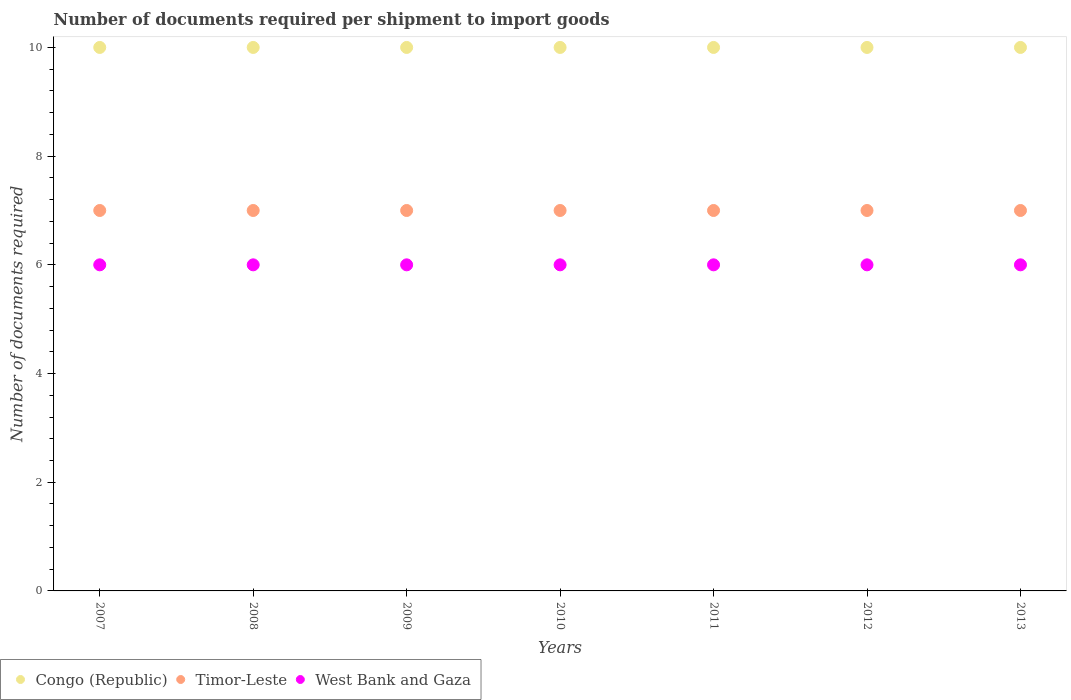How many different coloured dotlines are there?
Ensure brevity in your answer.  3. Is the number of dotlines equal to the number of legend labels?
Make the answer very short. Yes. What is the number of documents required per shipment to import goods in West Bank and Gaza in 2009?
Offer a terse response. 6. Across all years, what is the maximum number of documents required per shipment to import goods in Timor-Leste?
Your answer should be very brief. 7. In which year was the number of documents required per shipment to import goods in Timor-Leste maximum?
Your answer should be compact. 2007. In which year was the number of documents required per shipment to import goods in Congo (Republic) minimum?
Make the answer very short. 2007. What is the total number of documents required per shipment to import goods in West Bank and Gaza in the graph?
Offer a very short reply. 42. What is the difference between the number of documents required per shipment to import goods in West Bank and Gaza in 2011 and that in 2012?
Your answer should be compact. 0. What is the difference between the number of documents required per shipment to import goods in Congo (Republic) in 2011 and the number of documents required per shipment to import goods in Timor-Leste in 2009?
Make the answer very short. 3. What is the average number of documents required per shipment to import goods in Timor-Leste per year?
Make the answer very short. 7. In the year 2007, what is the difference between the number of documents required per shipment to import goods in Timor-Leste and number of documents required per shipment to import goods in West Bank and Gaza?
Offer a terse response. 1. In how many years, is the number of documents required per shipment to import goods in Timor-Leste greater than 6.4?
Your answer should be very brief. 7. What is the difference between the highest and the second highest number of documents required per shipment to import goods in Timor-Leste?
Offer a very short reply. 0. What is the difference between the highest and the lowest number of documents required per shipment to import goods in Timor-Leste?
Provide a succinct answer. 0. In how many years, is the number of documents required per shipment to import goods in West Bank and Gaza greater than the average number of documents required per shipment to import goods in West Bank and Gaza taken over all years?
Offer a very short reply. 0. Does the number of documents required per shipment to import goods in Congo (Republic) monotonically increase over the years?
Provide a short and direct response. No. Is the number of documents required per shipment to import goods in Congo (Republic) strictly greater than the number of documents required per shipment to import goods in Timor-Leste over the years?
Give a very brief answer. Yes. How many dotlines are there?
Provide a short and direct response. 3. Does the graph contain grids?
Give a very brief answer. No. Where does the legend appear in the graph?
Ensure brevity in your answer.  Bottom left. How are the legend labels stacked?
Keep it short and to the point. Horizontal. What is the title of the graph?
Offer a terse response. Number of documents required per shipment to import goods. What is the label or title of the X-axis?
Ensure brevity in your answer.  Years. What is the label or title of the Y-axis?
Your answer should be very brief. Number of documents required. What is the Number of documents required of Timor-Leste in 2007?
Your answer should be compact. 7. What is the Number of documents required of West Bank and Gaza in 2007?
Provide a short and direct response. 6. What is the Number of documents required in Congo (Republic) in 2008?
Offer a terse response. 10. What is the Number of documents required of Timor-Leste in 2008?
Your answer should be compact. 7. What is the Number of documents required in West Bank and Gaza in 2008?
Provide a short and direct response. 6. What is the Number of documents required in Congo (Republic) in 2009?
Your response must be concise. 10. What is the Number of documents required in Timor-Leste in 2010?
Make the answer very short. 7. What is the Number of documents required of West Bank and Gaza in 2010?
Ensure brevity in your answer.  6. What is the Number of documents required of Congo (Republic) in 2011?
Give a very brief answer. 10. What is the Number of documents required of Timor-Leste in 2012?
Offer a very short reply. 7. What is the Number of documents required of Timor-Leste in 2013?
Provide a short and direct response. 7. Across all years, what is the maximum Number of documents required of Timor-Leste?
Keep it short and to the point. 7. Across all years, what is the maximum Number of documents required in West Bank and Gaza?
Your answer should be compact. 6. Across all years, what is the minimum Number of documents required of Congo (Republic)?
Offer a very short reply. 10. Across all years, what is the minimum Number of documents required in West Bank and Gaza?
Give a very brief answer. 6. What is the total Number of documents required in Congo (Republic) in the graph?
Your answer should be very brief. 70. What is the total Number of documents required in Timor-Leste in the graph?
Give a very brief answer. 49. What is the difference between the Number of documents required of Congo (Republic) in 2007 and that in 2008?
Keep it short and to the point. 0. What is the difference between the Number of documents required in Timor-Leste in 2007 and that in 2008?
Offer a terse response. 0. What is the difference between the Number of documents required in Congo (Republic) in 2007 and that in 2009?
Make the answer very short. 0. What is the difference between the Number of documents required in Timor-Leste in 2007 and that in 2009?
Keep it short and to the point. 0. What is the difference between the Number of documents required in Congo (Republic) in 2007 and that in 2011?
Ensure brevity in your answer.  0. What is the difference between the Number of documents required in West Bank and Gaza in 2007 and that in 2011?
Keep it short and to the point. 0. What is the difference between the Number of documents required of Timor-Leste in 2007 and that in 2012?
Offer a very short reply. 0. What is the difference between the Number of documents required of Congo (Republic) in 2007 and that in 2013?
Give a very brief answer. 0. What is the difference between the Number of documents required of Timor-Leste in 2007 and that in 2013?
Your answer should be compact. 0. What is the difference between the Number of documents required in West Bank and Gaza in 2007 and that in 2013?
Give a very brief answer. 0. What is the difference between the Number of documents required of Congo (Republic) in 2008 and that in 2009?
Offer a terse response. 0. What is the difference between the Number of documents required in West Bank and Gaza in 2008 and that in 2011?
Your answer should be very brief. 0. What is the difference between the Number of documents required of West Bank and Gaza in 2008 and that in 2012?
Offer a terse response. 0. What is the difference between the Number of documents required in Congo (Republic) in 2008 and that in 2013?
Your response must be concise. 0. What is the difference between the Number of documents required in Congo (Republic) in 2009 and that in 2010?
Offer a terse response. 0. What is the difference between the Number of documents required in Timor-Leste in 2009 and that in 2010?
Offer a terse response. 0. What is the difference between the Number of documents required of West Bank and Gaza in 2009 and that in 2010?
Make the answer very short. 0. What is the difference between the Number of documents required in West Bank and Gaza in 2009 and that in 2012?
Provide a succinct answer. 0. What is the difference between the Number of documents required in Congo (Republic) in 2009 and that in 2013?
Your answer should be very brief. 0. What is the difference between the Number of documents required in Timor-Leste in 2009 and that in 2013?
Provide a short and direct response. 0. What is the difference between the Number of documents required in Timor-Leste in 2010 and that in 2011?
Make the answer very short. 0. What is the difference between the Number of documents required in Timor-Leste in 2010 and that in 2012?
Provide a short and direct response. 0. What is the difference between the Number of documents required in West Bank and Gaza in 2010 and that in 2012?
Your answer should be compact. 0. What is the difference between the Number of documents required in Congo (Republic) in 2010 and that in 2013?
Your response must be concise. 0. What is the difference between the Number of documents required of Timor-Leste in 2010 and that in 2013?
Your answer should be compact. 0. What is the difference between the Number of documents required of Congo (Republic) in 2011 and that in 2012?
Your answer should be compact. 0. What is the difference between the Number of documents required of Congo (Republic) in 2011 and that in 2013?
Ensure brevity in your answer.  0. What is the difference between the Number of documents required of Congo (Republic) in 2012 and that in 2013?
Keep it short and to the point. 0. What is the difference between the Number of documents required in West Bank and Gaza in 2012 and that in 2013?
Your answer should be very brief. 0. What is the difference between the Number of documents required of Congo (Republic) in 2007 and the Number of documents required of Timor-Leste in 2008?
Offer a very short reply. 3. What is the difference between the Number of documents required in Timor-Leste in 2007 and the Number of documents required in West Bank and Gaza in 2008?
Provide a short and direct response. 1. What is the difference between the Number of documents required of Congo (Republic) in 2007 and the Number of documents required of West Bank and Gaza in 2009?
Keep it short and to the point. 4. What is the difference between the Number of documents required in Congo (Republic) in 2007 and the Number of documents required in Timor-Leste in 2010?
Your answer should be compact. 3. What is the difference between the Number of documents required in Congo (Republic) in 2007 and the Number of documents required in West Bank and Gaza in 2011?
Your answer should be very brief. 4. What is the difference between the Number of documents required in Congo (Republic) in 2007 and the Number of documents required in Timor-Leste in 2012?
Offer a very short reply. 3. What is the difference between the Number of documents required in Congo (Republic) in 2008 and the Number of documents required in West Bank and Gaza in 2009?
Your answer should be very brief. 4. What is the difference between the Number of documents required in Timor-Leste in 2008 and the Number of documents required in West Bank and Gaza in 2009?
Offer a terse response. 1. What is the difference between the Number of documents required in Congo (Republic) in 2008 and the Number of documents required in West Bank and Gaza in 2011?
Offer a very short reply. 4. What is the difference between the Number of documents required of Congo (Republic) in 2008 and the Number of documents required of West Bank and Gaza in 2012?
Provide a short and direct response. 4. What is the difference between the Number of documents required in Congo (Republic) in 2008 and the Number of documents required in West Bank and Gaza in 2013?
Your response must be concise. 4. What is the difference between the Number of documents required in Congo (Republic) in 2009 and the Number of documents required in Timor-Leste in 2010?
Offer a terse response. 3. What is the difference between the Number of documents required of Timor-Leste in 2009 and the Number of documents required of West Bank and Gaza in 2010?
Make the answer very short. 1. What is the difference between the Number of documents required of Congo (Republic) in 2009 and the Number of documents required of West Bank and Gaza in 2012?
Give a very brief answer. 4. What is the difference between the Number of documents required of Timor-Leste in 2009 and the Number of documents required of West Bank and Gaza in 2012?
Offer a very short reply. 1. What is the difference between the Number of documents required in Congo (Republic) in 2009 and the Number of documents required in Timor-Leste in 2013?
Give a very brief answer. 3. What is the difference between the Number of documents required in Timor-Leste in 2009 and the Number of documents required in West Bank and Gaza in 2013?
Offer a terse response. 1. What is the difference between the Number of documents required of Congo (Republic) in 2010 and the Number of documents required of Timor-Leste in 2011?
Offer a very short reply. 3. What is the difference between the Number of documents required in Congo (Republic) in 2010 and the Number of documents required in West Bank and Gaza in 2011?
Ensure brevity in your answer.  4. What is the difference between the Number of documents required of Congo (Republic) in 2010 and the Number of documents required of West Bank and Gaza in 2012?
Your answer should be very brief. 4. What is the difference between the Number of documents required of Congo (Republic) in 2010 and the Number of documents required of Timor-Leste in 2013?
Your answer should be compact. 3. What is the difference between the Number of documents required in Congo (Republic) in 2011 and the Number of documents required in Timor-Leste in 2012?
Your answer should be very brief. 3. What is the difference between the Number of documents required in Timor-Leste in 2011 and the Number of documents required in West Bank and Gaza in 2012?
Keep it short and to the point. 1. What is the difference between the Number of documents required in Congo (Republic) in 2011 and the Number of documents required in Timor-Leste in 2013?
Give a very brief answer. 3. What is the difference between the Number of documents required of Congo (Republic) in 2011 and the Number of documents required of West Bank and Gaza in 2013?
Keep it short and to the point. 4. What is the difference between the Number of documents required in Timor-Leste in 2012 and the Number of documents required in West Bank and Gaza in 2013?
Keep it short and to the point. 1. What is the average Number of documents required of Timor-Leste per year?
Your response must be concise. 7. In the year 2007, what is the difference between the Number of documents required of Congo (Republic) and Number of documents required of Timor-Leste?
Provide a succinct answer. 3. In the year 2007, what is the difference between the Number of documents required of Timor-Leste and Number of documents required of West Bank and Gaza?
Give a very brief answer. 1. In the year 2008, what is the difference between the Number of documents required of Timor-Leste and Number of documents required of West Bank and Gaza?
Offer a terse response. 1. In the year 2009, what is the difference between the Number of documents required of Congo (Republic) and Number of documents required of West Bank and Gaza?
Your answer should be very brief. 4. In the year 2010, what is the difference between the Number of documents required in Congo (Republic) and Number of documents required in West Bank and Gaza?
Make the answer very short. 4. In the year 2010, what is the difference between the Number of documents required in Timor-Leste and Number of documents required in West Bank and Gaza?
Provide a short and direct response. 1. In the year 2011, what is the difference between the Number of documents required in Congo (Republic) and Number of documents required in West Bank and Gaza?
Provide a succinct answer. 4. In the year 2012, what is the difference between the Number of documents required of Congo (Republic) and Number of documents required of Timor-Leste?
Offer a terse response. 3. In the year 2012, what is the difference between the Number of documents required in Congo (Republic) and Number of documents required in West Bank and Gaza?
Ensure brevity in your answer.  4. In the year 2013, what is the difference between the Number of documents required of Congo (Republic) and Number of documents required of Timor-Leste?
Your answer should be compact. 3. In the year 2013, what is the difference between the Number of documents required of Timor-Leste and Number of documents required of West Bank and Gaza?
Make the answer very short. 1. What is the ratio of the Number of documents required in Congo (Republic) in 2007 to that in 2008?
Your answer should be compact. 1. What is the ratio of the Number of documents required in West Bank and Gaza in 2007 to that in 2008?
Your answer should be compact. 1. What is the ratio of the Number of documents required of Congo (Republic) in 2007 to that in 2009?
Provide a short and direct response. 1. What is the ratio of the Number of documents required in Timor-Leste in 2007 to that in 2009?
Your answer should be very brief. 1. What is the ratio of the Number of documents required of West Bank and Gaza in 2007 to that in 2009?
Provide a succinct answer. 1. What is the ratio of the Number of documents required in Timor-Leste in 2007 to that in 2010?
Your answer should be very brief. 1. What is the ratio of the Number of documents required in Timor-Leste in 2007 to that in 2012?
Offer a very short reply. 1. What is the ratio of the Number of documents required of West Bank and Gaza in 2007 to that in 2012?
Your response must be concise. 1. What is the ratio of the Number of documents required of Congo (Republic) in 2007 to that in 2013?
Your answer should be compact. 1. What is the ratio of the Number of documents required in West Bank and Gaza in 2007 to that in 2013?
Offer a terse response. 1. What is the ratio of the Number of documents required in Congo (Republic) in 2008 to that in 2009?
Keep it short and to the point. 1. What is the ratio of the Number of documents required of Congo (Republic) in 2008 to that in 2010?
Keep it short and to the point. 1. What is the ratio of the Number of documents required of West Bank and Gaza in 2008 to that in 2010?
Make the answer very short. 1. What is the ratio of the Number of documents required in Timor-Leste in 2008 to that in 2011?
Provide a short and direct response. 1. What is the ratio of the Number of documents required in West Bank and Gaza in 2008 to that in 2011?
Provide a short and direct response. 1. What is the ratio of the Number of documents required of Timor-Leste in 2008 to that in 2012?
Provide a short and direct response. 1. What is the ratio of the Number of documents required of West Bank and Gaza in 2008 to that in 2012?
Make the answer very short. 1. What is the ratio of the Number of documents required in Timor-Leste in 2008 to that in 2013?
Your answer should be compact. 1. What is the ratio of the Number of documents required of Congo (Republic) in 2009 to that in 2010?
Make the answer very short. 1. What is the ratio of the Number of documents required in Timor-Leste in 2009 to that in 2010?
Make the answer very short. 1. What is the ratio of the Number of documents required of Congo (Republic) in 2009 to that in 2011?
Ensure brevity in your answer.  1. What is the ratio of the Number of documents required of West Bank and Gaza in 2009 to that in 2011?
Keep it short and to the point. 1. What is the ratio of the Number of documents required of Congo (Republic) in 2009 to that in 2012?
Your answer should be very brief. 1. What is the ratio of the Number of documents required in Timor-Leste in 2009 to that in 2012?
Ensure brevity in your answer.  1. What is the ratio of the Number of documents required in West Bank and Gaza in 2010 to that in 2011?
Offer a very short reply. 1. What is the ratio of the Number of documents required in Congo (Republic) in 2010 to that in 2012?
Your answer should be very brief. 1. What is the ratio of the Number of documents required of West Bank and Gaza in 2010 to that in 2012?
Provide a short and direct response. 1. What is the ratio of the Number of documents required in West Bank and Gaza in 2010 to that in 2013?
Your answer should be compact. 1. What is the ratio of the Number of documents required of Congo (Republic) in 2011 to that in 2012?
Your response must be concise. 1. What is the ratio of the Number of documents required of Congo (Republic) in 2011 to that in 2013?
Ensure brevity in your answer.  1. What is the ratio of the Number of documents required of Timor-Leste in 2011 to that in 2013?
Provide a succinct answer. 1. What is the ratio of the Number of documents required in Timor-Leste in 2012 to that in 2013?
Your answer should be compact. 1. What is the difference between the highest and the second highest Number of documents required of Congo (Republic)?
Ensure brevity in your answer.  0. What is the difference between the highest and the second highest Number of documents required in Timor-Leste?
Your answer should be very brief. 0. What is the difference between the highest and the second highest Number of documents required in West Bank and Gaza?
Your response must be concise. 0. What is the difference between the highest and the lowest Number of documents required of Congo (Republic)?
Ensure brevity in your answer.  0. What is the difference between the highest and the lowest Number of documents required in Timor-Leste?
Give a very brief answer. 0. What is the difference between the highest and the lowest Number of documents required in West Bank and Gaza?
Offer a very short reply. 0. 